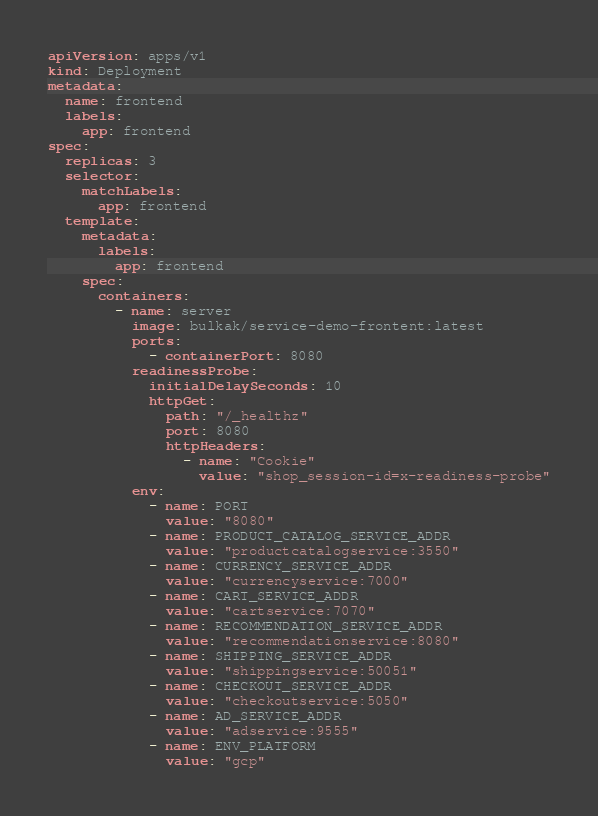<code> <loc_0><loc_0><loc_500><loc_500><_YAML_>apiVersion: apps/v1
kind: Deployment
metadata:
  name: frontend
  labels:
    app: frontend
spec:
  replicas: 3
  selector:
    matchLabels:
      app: frontend
  template:
    metadata:
      labels:
        app: frontend
    spec:
      containers:
        - name: server
          image: bulkak/service-demo-frontent:latest
          ports:
            - containerPort: 8080
          readinessProbe:
            initialDelaySeconds: 10
            httpGet:
              path: "/_healthz"
              port: 8080
              httpHeaders:
                - name: "Cookie"
                  value: "shop_session-id=x-readiness-probe"
          env:
            - name: PORT
              value: "8080"
            - name: PRODUCT_CATALOG_SERVICE_ADDR
              value: "productcatalogservice:3550"
            - name: CURRENCY_SERVICE_ADDR
              value: "currencyservice:7000"
            - name: CART_SERVICE_ADDR
              value: "cartservice:7070"
            - name: RECOMMENDATION_SERVICE_ADDR
              value: "recommendationservice:8080"
            - name: SHIPPING_SERVICE_ADDR
              value: "shippingservice:50051"
            - name: CHECKOUT_SERVICE_ADDR
              value: "checkoutservice:5050"
            - name: AD_SERVICE_ADDR
              value: "adservice:9555"
            - name: ENV_PLATFORM
              value: "gcp"</code> 